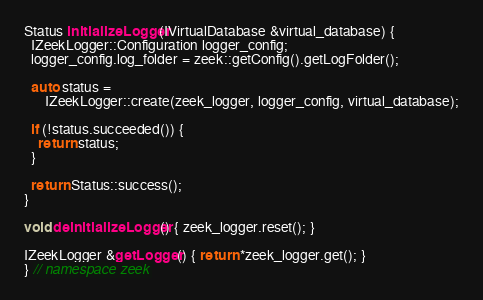Convert code to text. <code><loc_0><loc_0><loc_500><loc_500><_C++_>
Status initializeLogger(IVirtualDatabase &virtual_database) {
  IZeekLogger::Configuration logger_config;
  logger_config.log_folder = zeek::getConfig().getLogFolder();

  auto status =
      IZeekLogger::create(zeek_logger, logger_config, virtual_database);

  if (!status.succeeded()) {
    return status;
  }

  return Status::success();
}

void deinitializeLogger() { zeek_logger.reset(); }

IZeekLogger &getLogger() { return *zeek_logger.get(); }
} // namespace zeek
</code> 